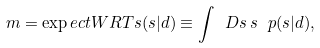Convert formula to latex. <formula><loc_0><loc_0><loc_500><loc_500>m = \exp e c t W R T { s } { ( s | d ) } \equiv \int \ D s \, s \, \ p ( s | d ) ,</formula> 